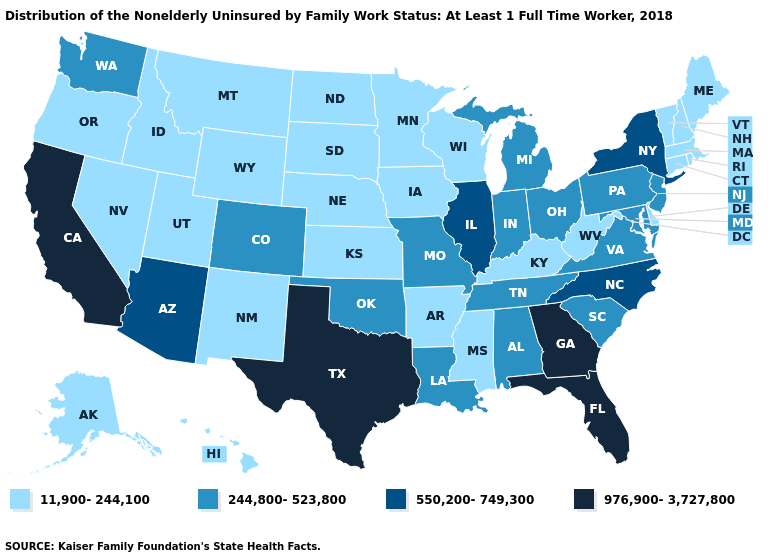Is the legend a continuous bar?
Short answer required. No. Name the states that have a value in the range 244,800-523,800?
Be succinct. Alabama, Colorado, Indiana, Louisiana, Maryland, Michigan, Missouri, New Jersey, Ohio, Oklahoma, Pennsylvania, South Carolina, Tennessee, Virginia, Washington. Does California have the highest value in the USA?
Short answer required. Yes. Does New Hampshire have the same value as Nevada?
Concise answer only. Yes. Among the states that border Virginia , which have the highest value?
Answer briefly. North Carolina. Name the states that have a value in the range 976,900-3,727,800?
Give a very brief answer. California, Florida, Georgia, Texas. Which states have the lowest value in the USA?
Be succinct. Alaska, Arkansas, Connecticut, Delaware, Hawaii, Idaho, Iowa, Kansas, Kentucky, Maine, Massachusetts, Minnesota, Mississippi, Montana, Nebraska, Nevada, New Hampshire, New Mexico, North Dakota, Oregon, Rhode Island, South Dakota, Utah, Vermont, West Virginia, Wisconsin, Wyoming. Which states have the lowest value in the South?
Give a very brief answer. Arkansas, Delaware, Kentucky, Mississippi, West Virginia. Name the states that have a value in the range 550,200-749,300?
Give a very brief answer. Arizona, Illinois, New York, North Carolina. Does Massachusetts have the lowest value in the Northeast?
Short answer required. Yes. Does Florida have the lowest value in the USA?
Keep it brief. No. Which states hav the highest value in the MidWest?
Short answer required. Illinois. Name the states that have a value in the range 11,900-244,100?
Concise answer only. Alaska, Arkansas, Connecticut, Delaware, Hawaii, Idaho, Iowa, Kansas, Kentucky, Maine, Massachusetts, Minnesota, Mississippi, Montana, Nebraska, Nevada, New Hampshire, New Mexico, North Dakota, Oregon, Rhode Island, South Dakota, Utah, Vermont, West Virginia, Wisconsin, Wyoming. Name the states that have a value in the range 976,900-3,727,800?
Quick response, please. California, Florida, Georgia, Texas. Does the map have missing data?
Short answer required. No. 